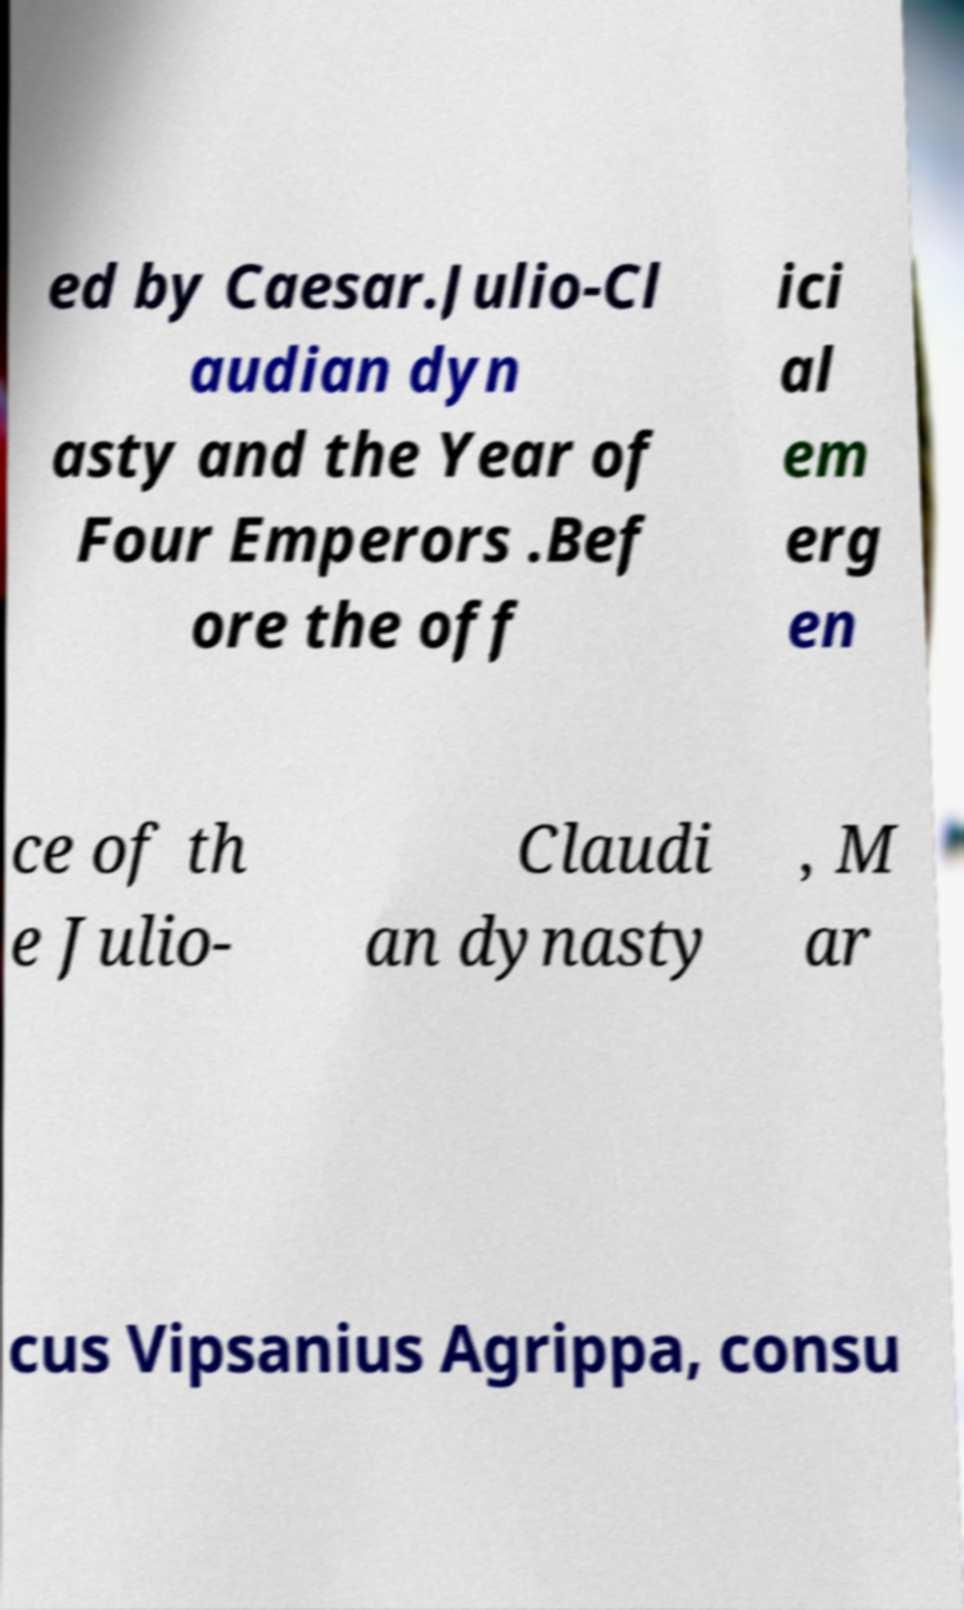Please identify and transcribe the text found in this image. ed by Caesar.Julio-Cl audian dyn asty and the Year of Four Emperors .Bef ore the off ici al em erg en ce of th e Julio- Claudi an dynasty , M ar cus Vipsanius Agrippa, consu 